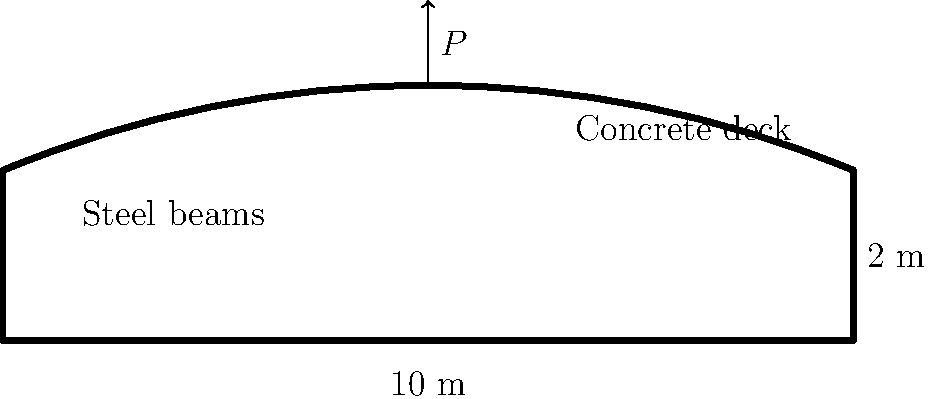A bridge with a span of 10 meters and a height of 2 meters is constructed using steel beams and a concrete deck, as shown in the diagram. The bridge is designed to support a maximum point load $P$ at its center. Given that the steel beams have a yield strength of 250 MPa and the concrete deck has a compressive strength of 30 MPa, calculate the maximum point load $P$ that the bridge can safely support. Assume a safety factor of 1.5 and that the bending moment at the center of the bridge is the critical factor. To determine the maximum point load $P$, we'll follow these steps:

1) The maximum bending moment $M_{max}$ occurs at the center of the bridge and is given by:
   $$M_{max} = \frac{PL}{4}$$
   where $L$ is the span length (10 m).

2) The section modulus $S$ of the bridge can be estimated using:
   $$S = \frac{bh^2}{6}$$
   where $b$ is the width (assume 1 m) and $h$ is the height (2 m).
   $$S = \frac{1 \times 2^2}{6} = 0.667 \text{ m}^3$$

3) The allowable stress $\sigma_{allow}$ is the yield strength divided by the safety factor:
   $$\sigma_{allow} = \frac{250 \text{ MPa}}{1.5} = 166.67 \text{ MPa}$$

4) The maximum allowable bending moment is:
   $$M_{allow} = \sigma_{allow} \times S = 166.67 \times 10^6 \times 0.667 = 111,111,111 \text{ N·m}$$

5) Equating this to the maximum bending moment due to the point load:
   $$\frac{PL}{4} = 111,111,111$$
   $$P \times 10 = 4 \times 111,111,111$$
   $$P = \frac{4 \times 111,111,111}{10} = 44,444,444 \text{ N}$$

6) Convert to kN:
   $$P = 44,444 \text{ kN}$$
Answer: 44,444 kN 